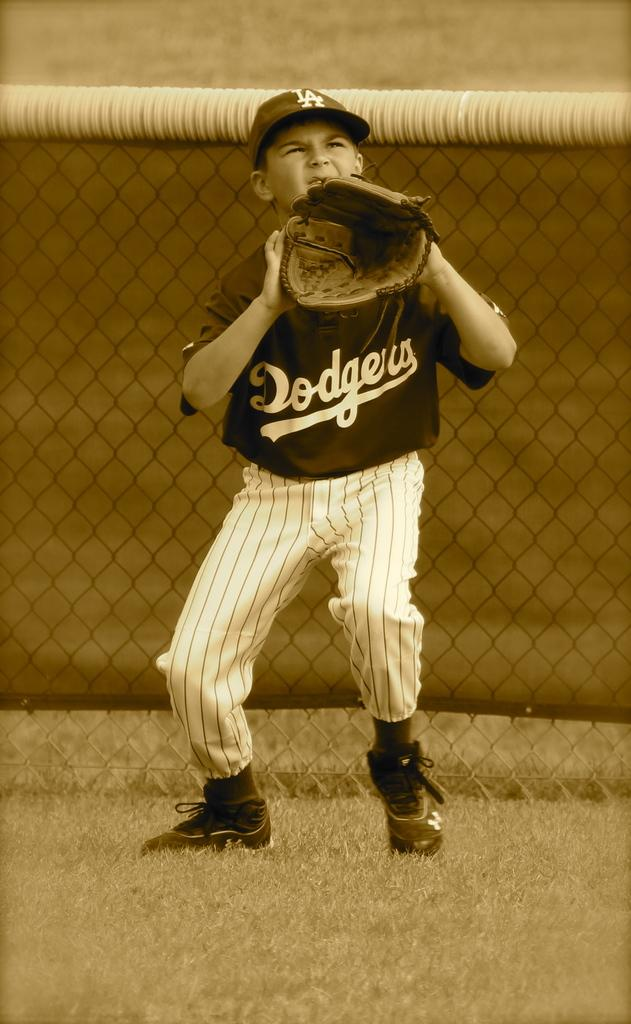Provide a one-sentence caption for the provided image. Older picture of a kid on the dodgers team playing baseball in the outfield. 